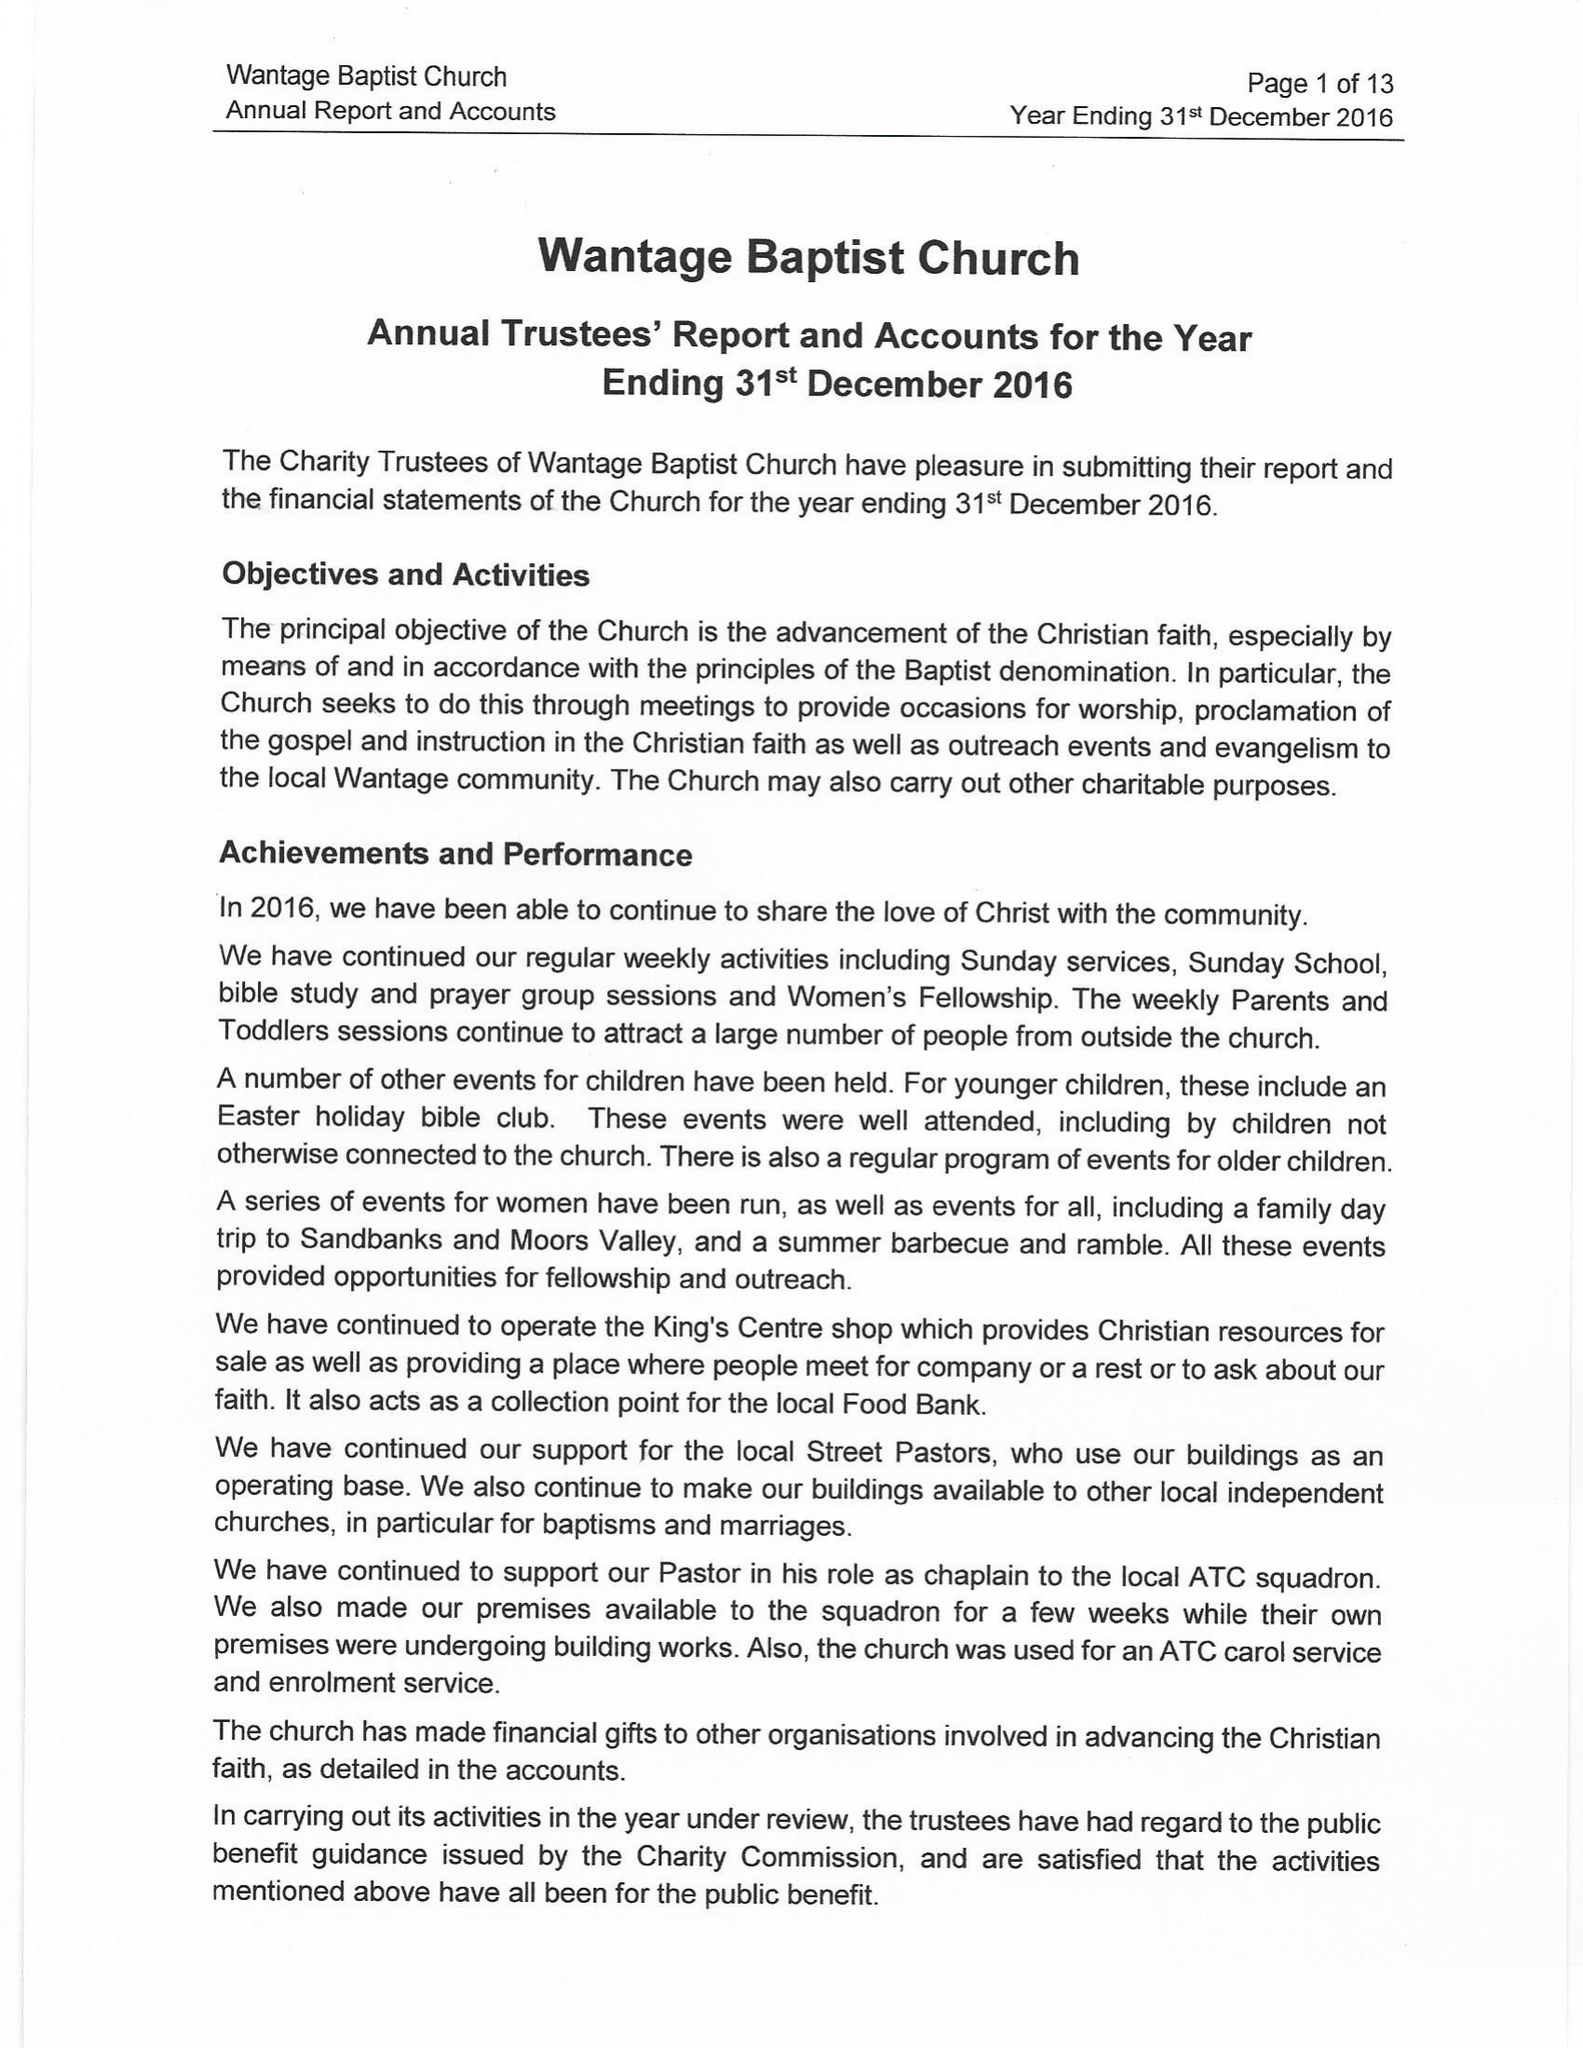What is the value for the spending_annually_in_british_pounds?
Answer the question using a single word or phrase. 94378.00 